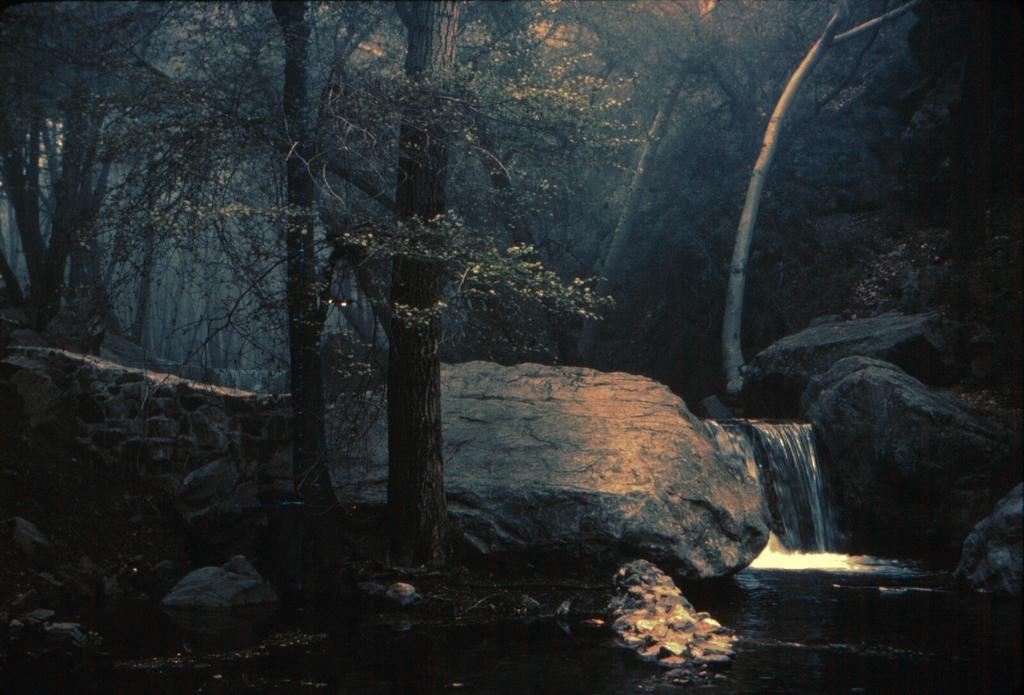In one or two sentences, can you explain what this image depicts? In the left side there are trees and in the right side the water is flowing from the stones. 